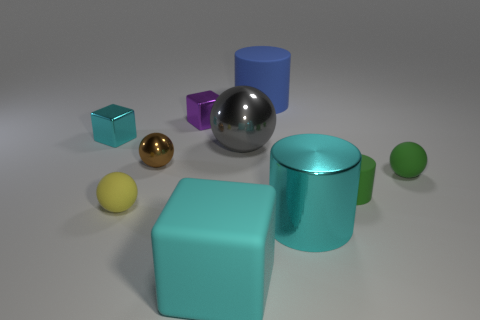There is a green cylinder that is made of the same material as the yellow ball; what size is it?
Provide a short and direct response. Small. Are there any balls that have the same color as the large matte block?
Keep it short and to the point. No. What number of things are red cylinders or small purple things behind the yellow matte object?
Keep it short and to the point. 1. Are there more tiny purple metal cylinders than purple blocks?
Offer a terse response. No. What size is the metallic cylinder that is the same color as the large cube?
Ensure brevity in your answer.  Large. Are there any gray objects that have the same material as the green ball?
Your answer should be very brief. No. There is a tiny object that is right of the large gray ball and on the left side of the green rubber sphere; what shape is it?
Ensure brevity in your answer.  Cylinder. How many other objects are there of the same shape as the large cyan shiny thing?
Offer a very short reply. 2. How big is the green rubber sphere?
Your answer should be compact. Small. What number of objects are either big gray balls or large brown things?
Your answer should be very brief. 1. 